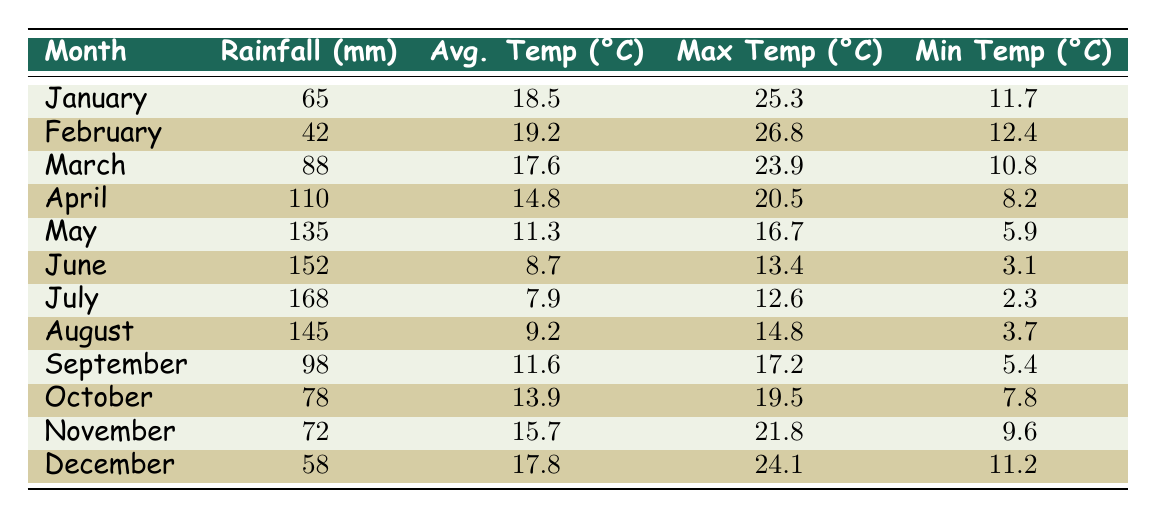What is the total rainfall in May? From the table, we can see that the rainfall in May is 135 mm. Since the question asks for the specific month's rainfall, we refer directly to that value.
Answer: 135 mm Which month had the highest average temperature? By scanning the "Avg. Temp (°C)" column in the table, we find that February has the highest average temperature at 19.2°C.
Answer: February What is the difference between maximum and minimum temperature in December? The maximum temperature in December is 24.1°C and the minimum is 11.2°C. The difference is calculated as 24.1 - 11.2 = 12.9°C.
Answer: 12.9°C How much more rainfall did April receive compared to March? April received 110 mm of rainfall while March received 88 mm. The difference is 110 - 88 = 22 mm, indicating that April had 22 mm more rainfall than March.
Answer: 22 mm Did June have a higher average temperature than July? Looking at the "Avg. Temp (°C)" column, June's average temperature is 8.7°C and July's is 7.9°C. Since 8.7°C is greater than 7.9°C, the answer is yes.
Answer: Yes What is the average rainfall for the first half of the year (January to June)? Adding the rainfall for January (65 mm), February (42 mm), March (88 mm), April (110 mm), May (135 mm), and June (152 mm), we get 65 + 42 + 88 + 110 + 135 + 152 = 592 mm. To find the average, we divide by 6 months: 592 / 6 = 98.67 mm.
Answer: 98.67 mm Which month had the least amount of rainfall? By reviewing the "Rainfall (mm)" column, we see that February had the least with 42 mm.
Answer: February What is the highest recorded maximum temperature throughout the year? The highest value in the "Max Temp (°C)" column is 26.8°C in February.
Answer: 26.8°C If we compare the total rainfall in the second half of the year (July to December) to the first half, which half had more rainfall? First half total: January (65 mm) + February (42 mm) + March (88 mm) + April (110 mm) + May (135 mm) + June (152 mm) = 592 mm. Second half total: July (168 mm) + August (145 mm) + September (98 mm) + October (78 mm) + November (72 mm) + December (58 mm) = 719 mm. Since 719 mm > 592 mm, the second half had more rainfall.
Answer: Second half What was the average low temperature for the whole year? To find the average, sum all the minimum temperatures: 11.7 + 12.4 + 10.8 + 8.2 + 5.9 + 3.1 + 2.3 + 3.7 + 5.4 + 7.8 + 9.6 + 11.2 = 78.1°C. Dividing this total by 12 gives us 78.1 / 12 = 6.51°C.
Answer: 6.51°C 